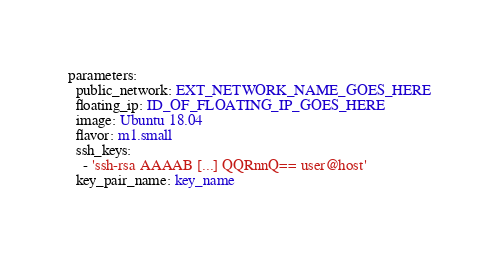Convert code to text. <code><loc_0><loc_0><loc_500><loc_500><_YAML_>parameters:
  public_network: EXT_NETWORK_NAME_GOES_HERE
  floating_ip: ID_OF_FLOATING_IP_GOES_HERE
  image: Ubuntu 18.04
  flavor: m1.small
  ssh_keys:
    - 'ssh-rsa AAAAB [...] QQRnnQ== user@host'
  key_pair_name: key_name
</code> 